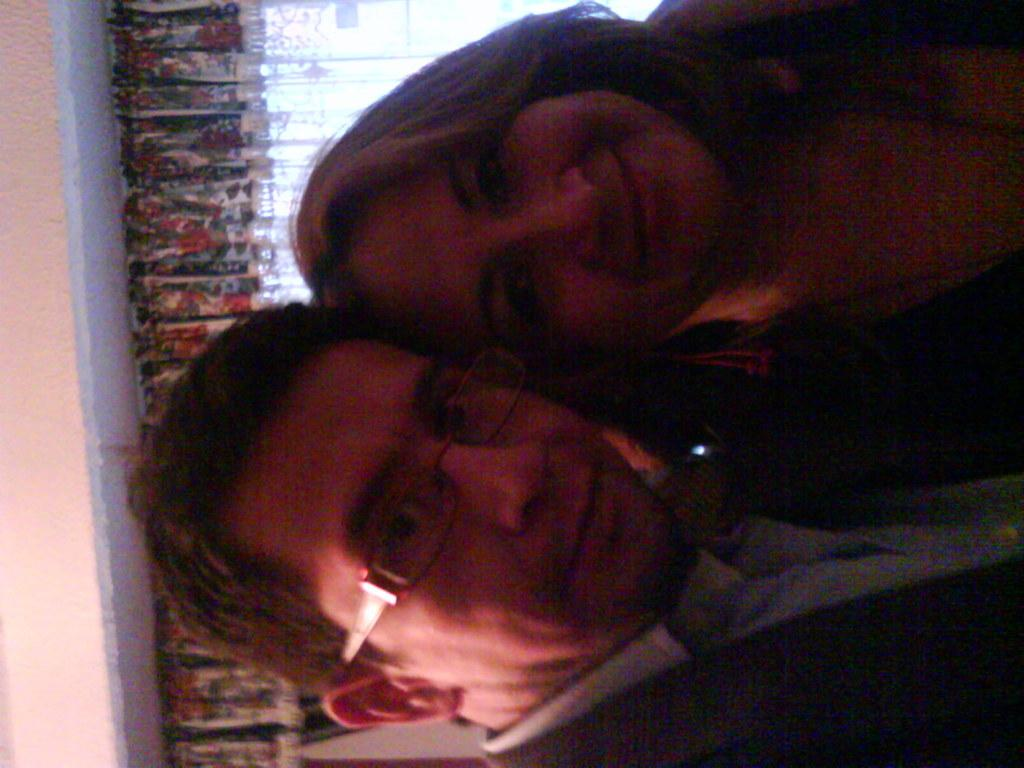Who are the two people in the foreground of the image? There is a man and a woman in the foreground of the image. What are the man and woman doing in the image? Both the man and woman are posing for a camera. What can be seen in the background of the image? There is a curtain and a wall in the background of the image. What type of doll is sitting on the table during the lunch scene in the image? There is no doll or lunch scene present in the image; it features a man and a woman posing for a camera with a curtain and wall in the background. 